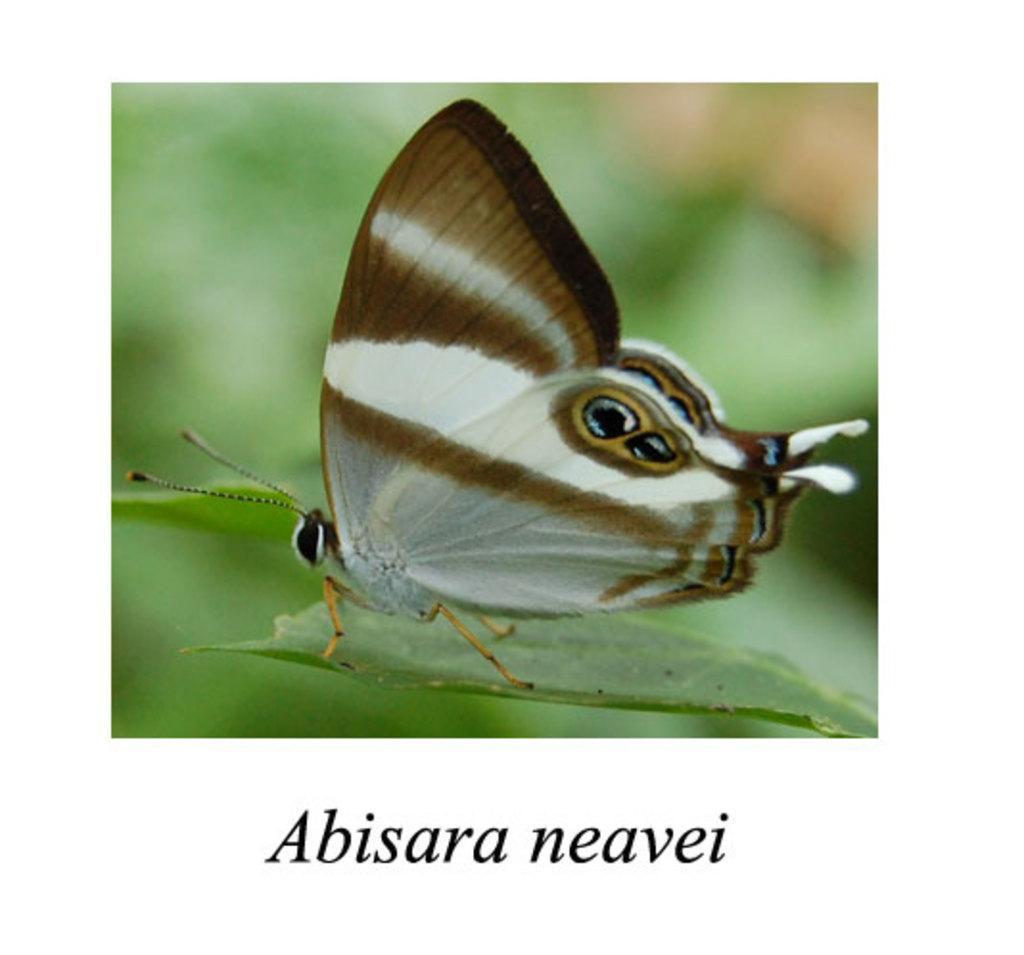Please provide a concise description of this image. This is an edited image. I can see a butterfly on a leaf. There is a blurred background. At the bottom of the image, I can see a watermark. 